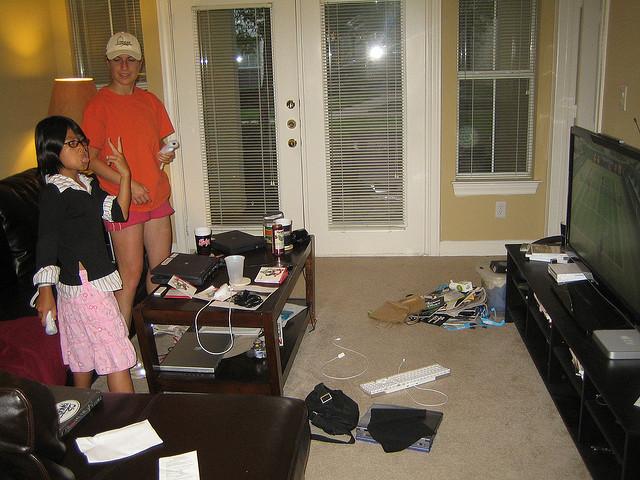What is the bag called that is on the floor?
Short answer required. Purse. Are there hardwood floors?
Quick response, please. No. What is in the girls hands?
Write a very short answer. Wii remote. Is this room cluttered?
Give a very brief answer. Yes. Is his laptop plugged in?
Concise answer only. No. Is the girl wearing glasses?
Be succinct. Yes. 